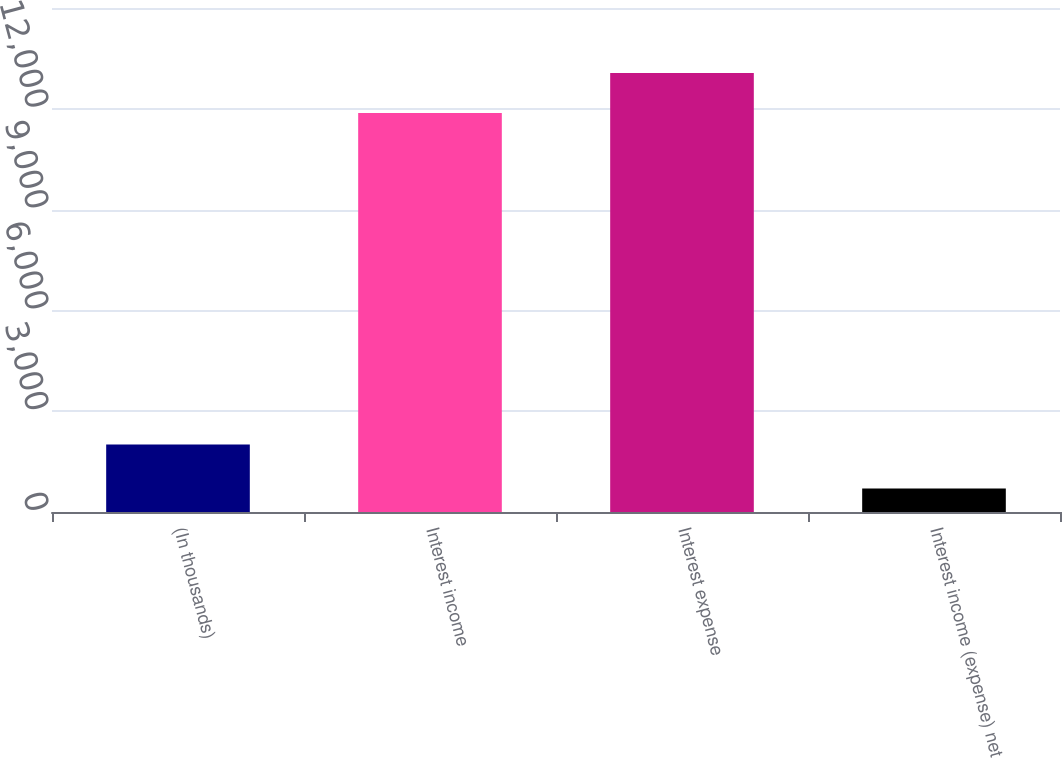Convert chart to OTSL. <chart><loc_0><loc_0><loc_500><loc_500><bar_chart><fcel>(In thousands)<fcel>Interest income<fcel>Interest expense<fcel>Interest income (expense) net<nl><fcel>2006<fcel>11877<fcel>13064.7<fcel>697<nl></chart> 